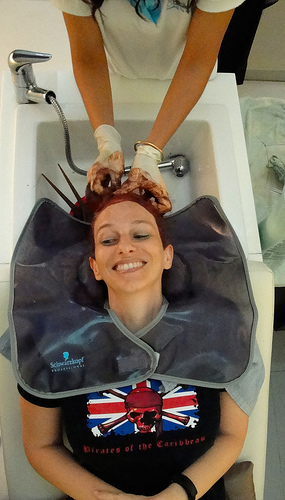<image>
Is there a woman on the sink? Yes. Looking at the image, I can see the woman is positioned on top of the sink, with the sink providing support. 